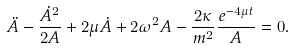Convert formula to latex. <formula><loc_0><loc_0><loc_500><loc_500>\ddot { A } - \frac { \dot { A } ^ { 2 } } { 2 A } + 2 \mu \dot { A } + 2 \omega ^ { 2 } A - \frac { 2 \kappa } { m ^ { 2 } } \frac { e ^ { - 4 \mu t } } { A } = 0 .</formula> 